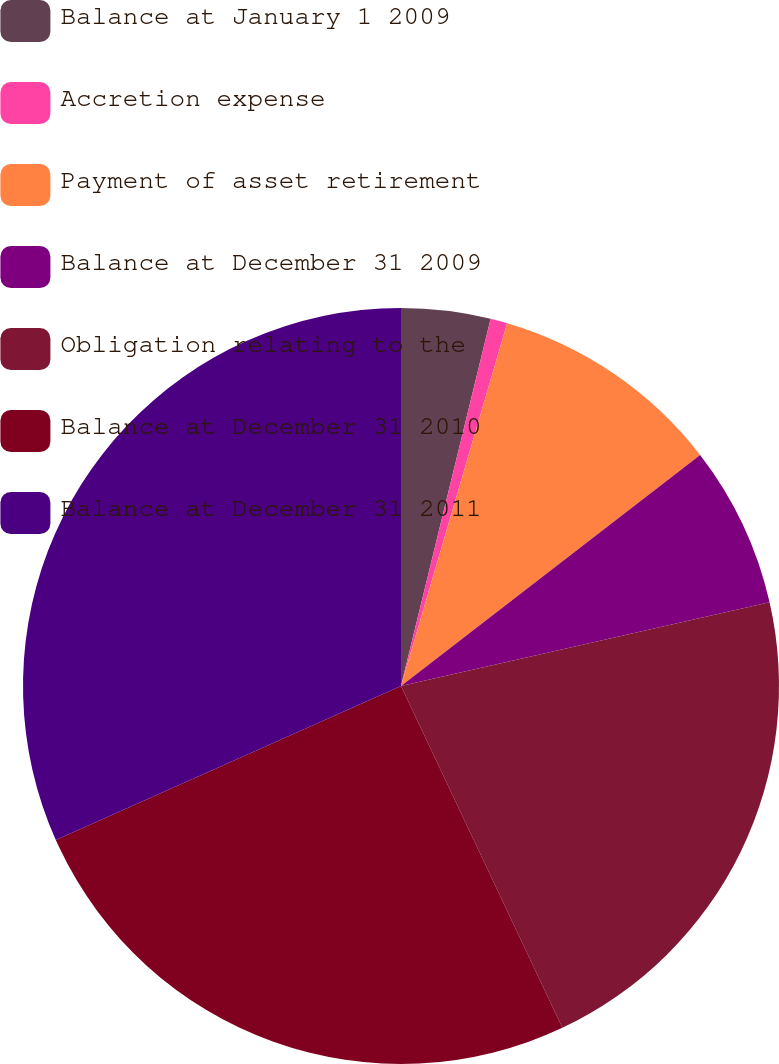Convert chart. <chart><loc_0><loc_0><loc_500><loc_500><pie_chart><fcel>Balance at January 1 2009<fcel>Accretion expense<fcel>Payment of asset retirement<fcel>Balance at December 31 2009<fcel>Obligation relating to the<fcel>Balance at December 31 2010<fcel>Balance at December 31 2011<nl><fcel>3.81%<fcel>0.72%<fcel>10.0%<fcel>6.91%<fcel>21.54%<fcel>25.34%<fcel>31.68%<nl></chart> 